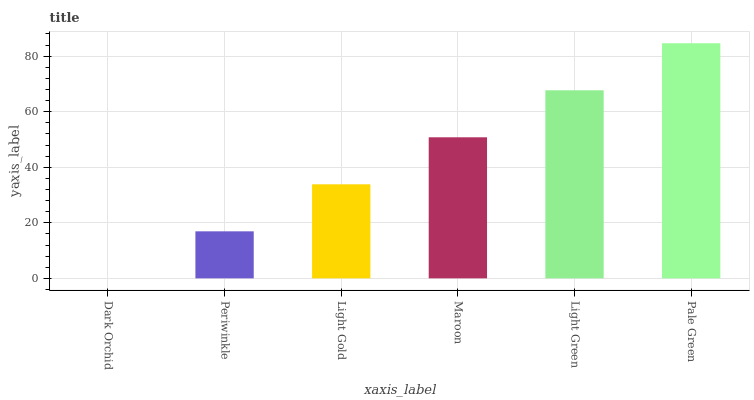Is Dark Orchid the minimum?
Answer yes or no. Yes. Is Pale Green the maximum?
Answer yes or no. Yes. Is Periwinkle the minimum?
Answer yes or no. No. Is Periwinkle the maximum?
Answer yes or no. No. Is Periwinkle greater than Dark Orchid?
Answer yes or no. Yes. Is Dark Orchid less than Periwinkle?
Answer yes or no. Yes. Is Dark Orchid greater than Periwinkle?
Answer yes or no. No. Is Periwinkle less than Dark Orchid?
Answer yes or no. No. Is Maroon the high median?
Answer yes or no. Yes. Is Light Gold the low median?
Answer yes or no. Yes. Is Dark Orchid the high median?
Answer yes or no. No. Is Dark Orchid the low median?
Answer yes or no. No. 